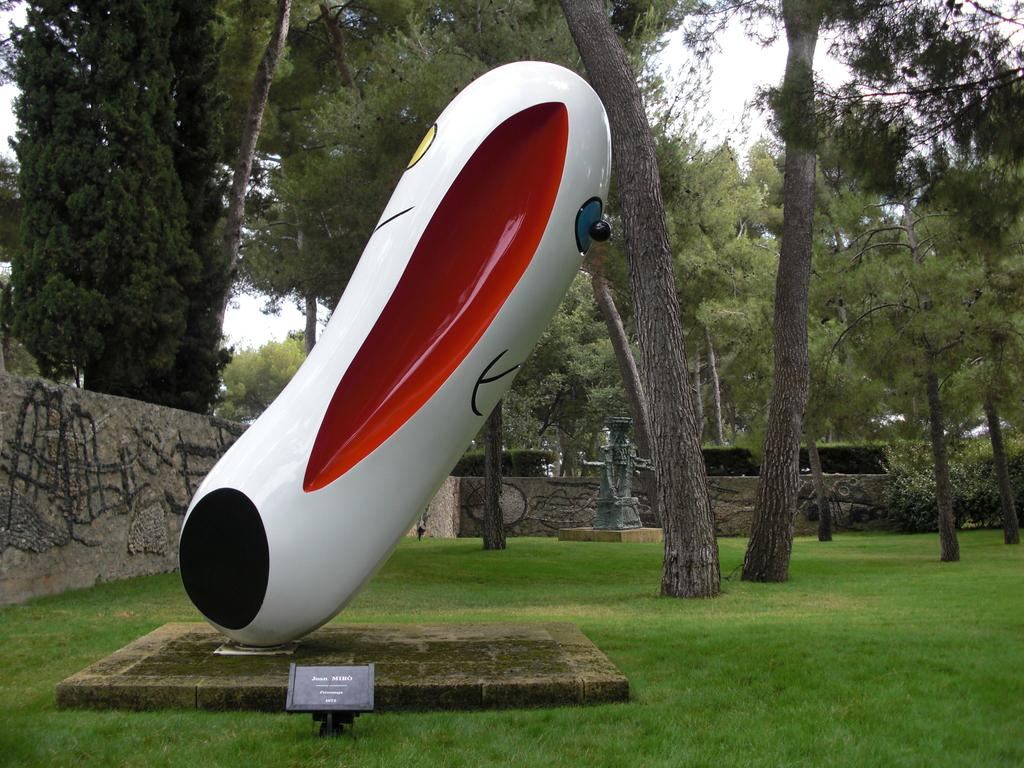What can be seen in the image that represents artistic creations? There are statues in the image. What surface is present in the image that might be used for displaying information or messages? There is a board in the image. What type of natural environment is visible in the image? There is grass in the image. What type of structure is present in the image? There is a wall in the image. What type of living organisms can be seen in the image? There are plants in the image. What can be seen in the background of the image that indicates the location? There are trees and the sky visible in the background of the image. What type of jeans can be seen hanging on the hook in the image? There is no hook or jeans present in the image. What type of exchange is taking place between the statues in the image? There is no exchange taking place between the statues in the image; they are stationary objects. 